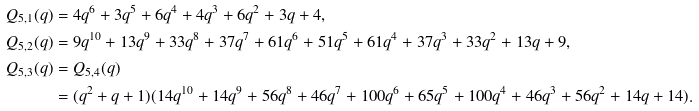Convert formula to latex. <formula><loc_0><loc_0><loc_500><loc_500>Q _ { 5 , 1 } ( q ) & = 4 q ^ { 6 } + 3 q ^ { 5 } + 6 q ^ { 4 } + 4 q ^ { 3 } + 6 q ^ { 2 } + 3 q + 4 , \\ Q _ { 5 , 2 } ( q ) & = 9 q ^ { 1 0 } + 1 3 q ^ { 9 } + 3 3 q ^ { 8 } + 3 7 q ^ { 7 } + 6 1 q ^ { 6 } + 5 1 q ^ { 5 } + 6 1 q ^ { 4 } + 3 7 q ^ { 3 } + 3 3 q ^ { 2 } + 1 3 q + 9 , \\ Q _ { 5 , 3 } ( q ) & = Q _ { 5 , 4 } ( q ) \\ & = ( q ^ { 2 } + q + 1 ) ( 1 4 q ^ { 1 0 } + 1 4 q ^ { 9 } + 5 6 q ^ { 8 } + 4 6 q ^ { 7 } + 1 0 0 q ^ { 6 } + 6 5 q ^ { 5 } + 1 0 0 q ^ { 4 } + 4 6 q ^ { 3 } + 5 6 q ^ { 2 } + 1 4 q + 1 4 ) .</formula> 